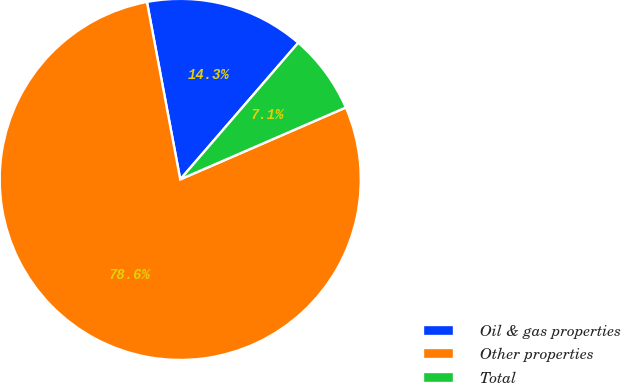Convert chart. <chart><loc_0><loc_0><loc_500><loc_500><pie_chart><fcel>Oil & gas properties<fcel>Other properties<fcel>Total<nl><fcel>14.29%<fcel>78.57%<fcel>7.14%<nl></chart> 